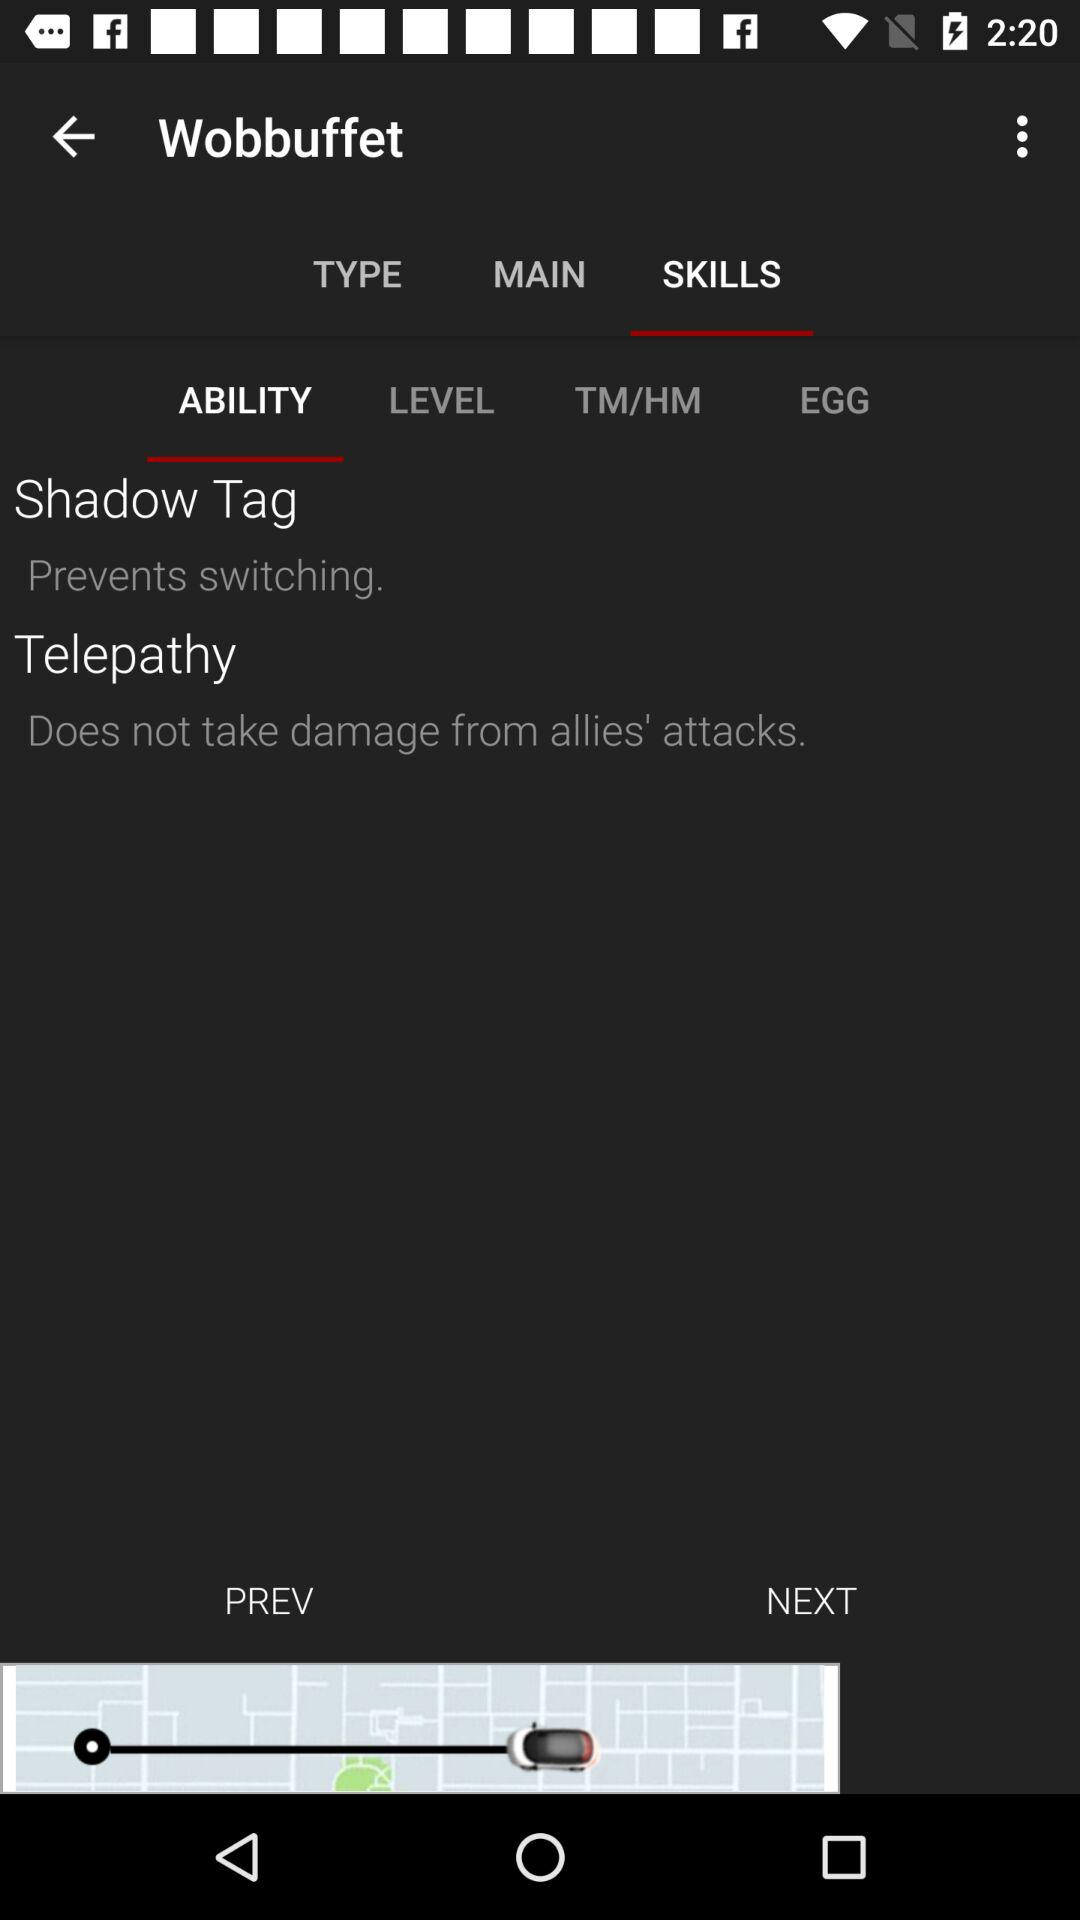How many abilities does Wobbuffet have?
Answer the question using a single word or phrase. 2 